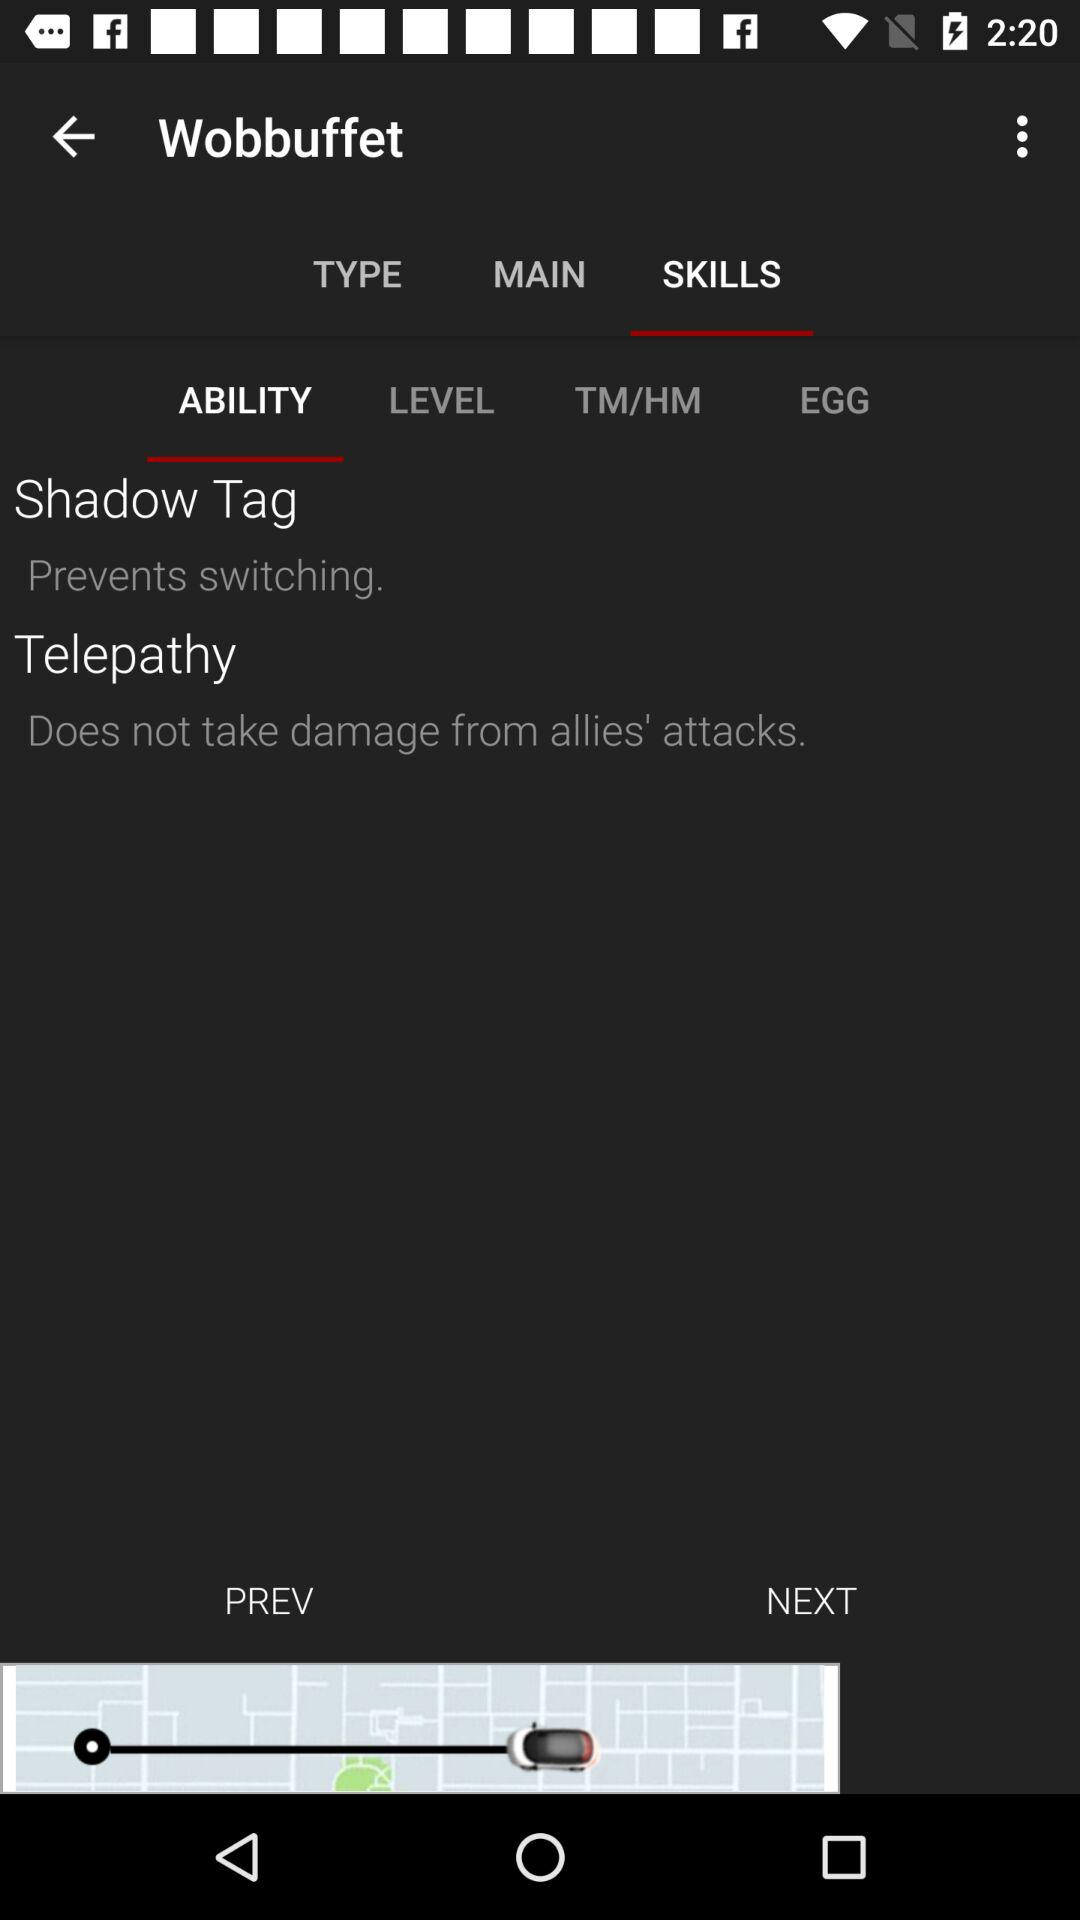How many abilities does Wobbuffet have?
Answer the question using a single word or phrase. 2 